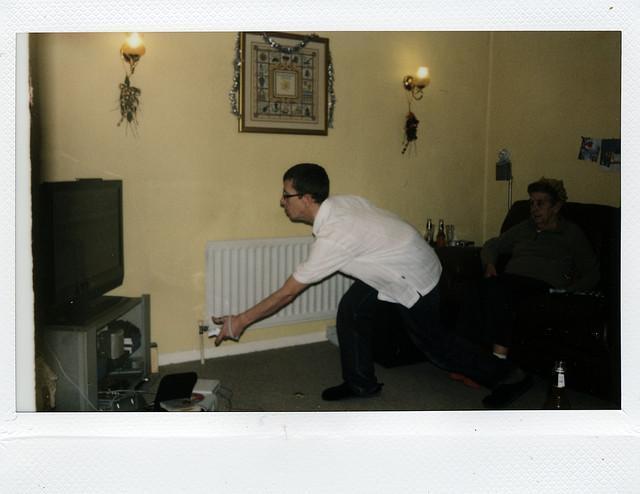How many people are in the picture?
Give a very brief answer. 2. How many people are visible?
Give a very brief answer. 2. 